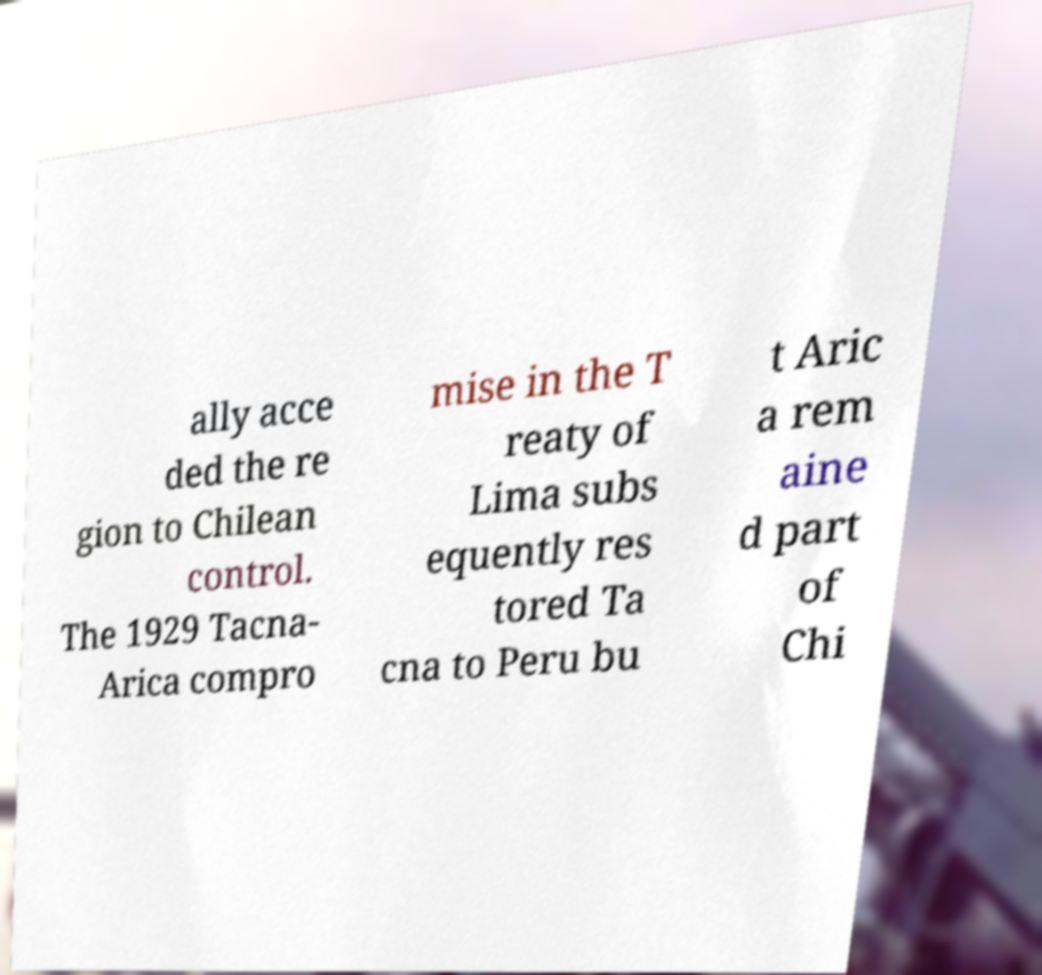What messages or text are displayed in this image? I need them in a readable, typed format. ally acce ded the re gion to Chilean control. The 1929 Tacna- Arica compro mise in the T reaty of Lima subs equently res tored Ta cna to Peru bu t Aric a rem aine d part of Chi 